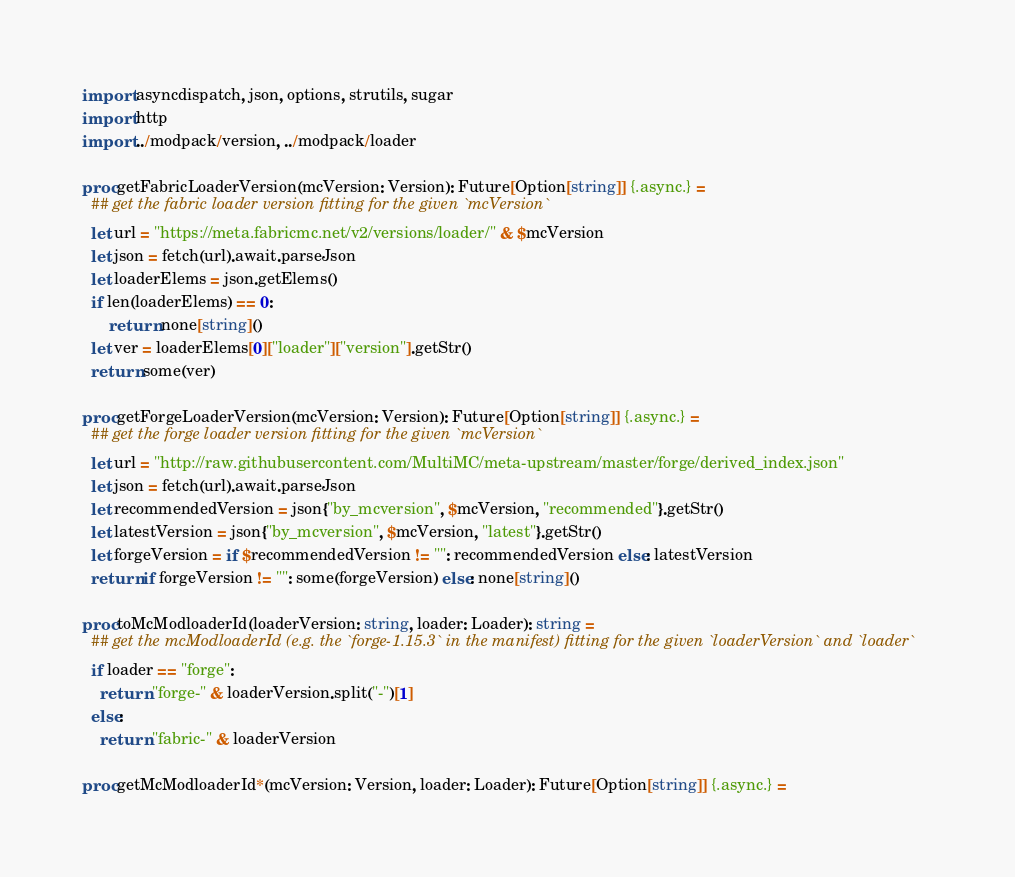Convert code to text. <code><loc_0><loc_0><loc_500><loc_500><_Nim_>import asyncdispatch, json, options, strutils, sugar
import http
import ../modpack/version, ../modpack/loader

proc getFabricLoaderVersion(mcVersion: Version): Future[Option[string]] {.async.} =
  ## get the fabric loader version fitting for the given `mcVersion`
  let url = "https://meta.fabricmc.net/v2/versions/loader/" & $mcVersion
  let json = fetch(url).await.parseJson
  let loaderElems = json.getElems()
  if len(loaderElems) == 0:
      return none[string]()
  let ver = loaderElems[0]["loader"]["version"].getStr()
  return some(ver)

proc getForgeLoaderVersion(mcVersion: Version): Future[Option[string]] {.async.} =
  ## get the forge loader version fitting for the given `mcVersion`
  let url = "http://raw.githubusercontent.com/MultiMC/meta-upstream/master/forge/derived_index.json"
  let json = fetch(url).await.parseJson
  let recommendedVersion = json{"by_mcversion", $mcVersion, "recommended"}.getStr()
  let latestVersion = json{"by_mcversion", $mcVersion, "latest"}.getStr()
  let forgeVersion = if $recommendedVersion != "": recommendedVersion else: latestVersion
  return if forgeVersion != "": some(forgeVersion) else: none[string]()

proc toMcModloaderId(loaderVersion: string, loader: Loader): string =
  ## get the mcModloaderId (e.g. the `forge-1.15.3` in the manifest) fitting for the given `loaderVersion` and `loader`
  if loader == "forge":
    return "forge-" & loaderVersion.split("-")[1]
  else:
    return "fabric-" & loaderVersion

proc getMcModloaderId*(mcVersion: Version, loader: Loader): Future[Option[string]] {.async.} =</code> 